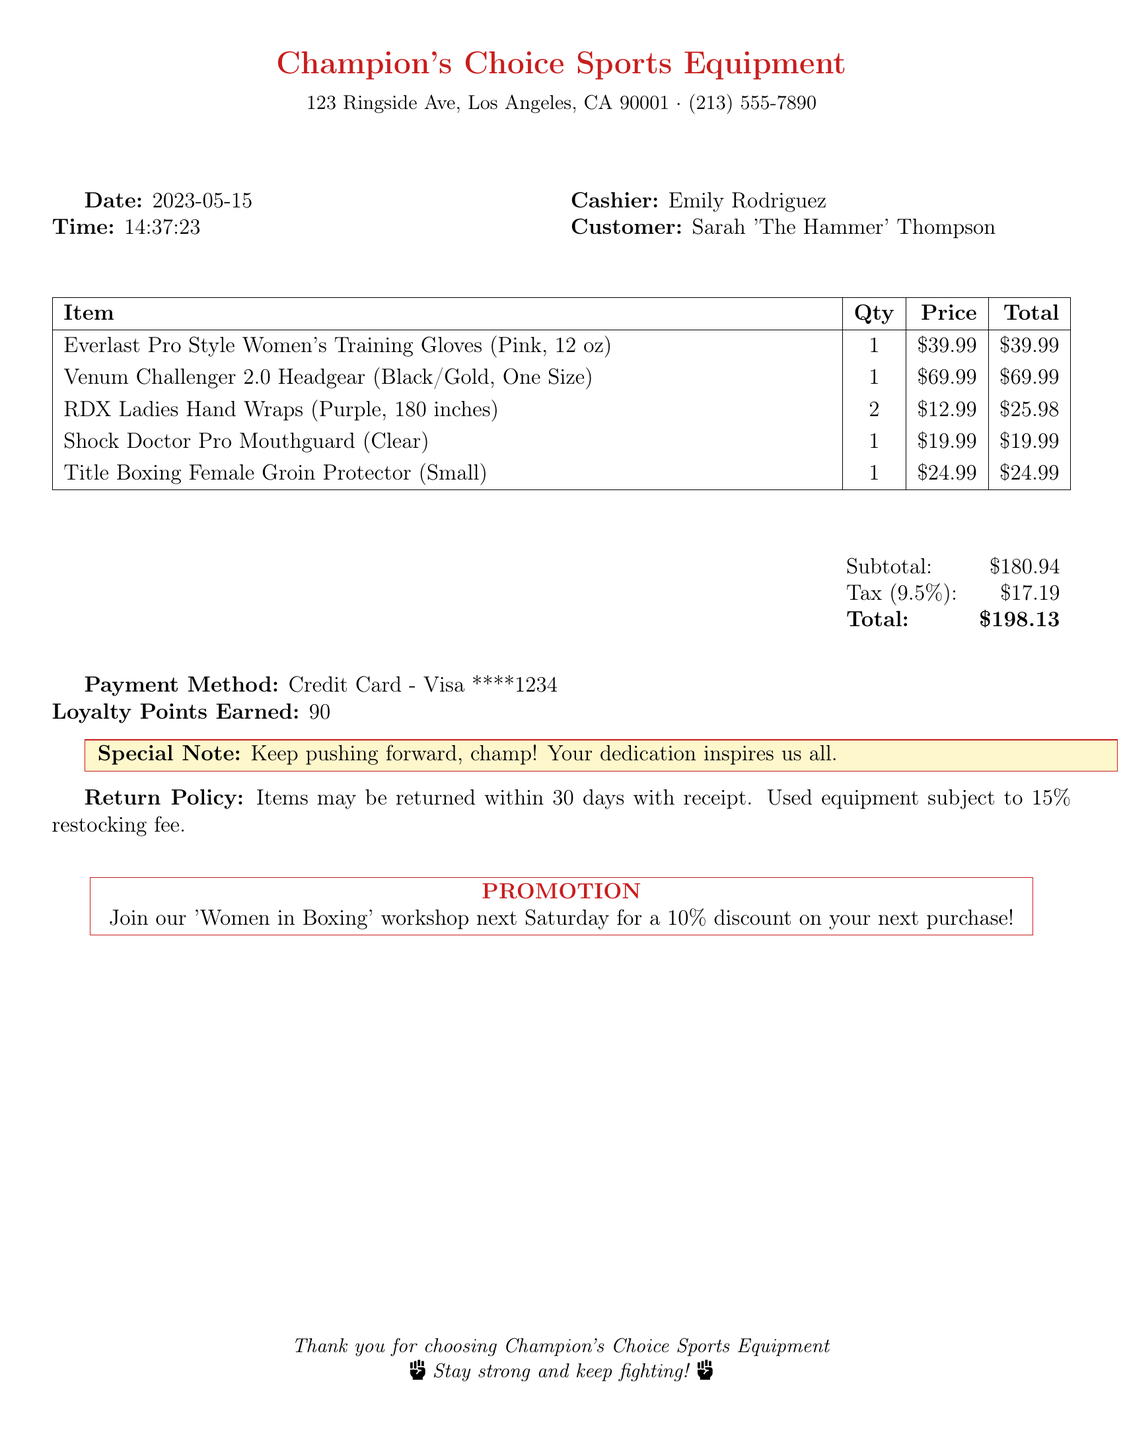What is the store name? The store name is located at the top of the receipt.
Answer: Champion's Choice Sports Equipment What is the total amount spent? The total amount is shown at the bottom of the receipt.
Answer: $198.13 What date was the purchase made? The date is listed in the receipt details.
Answer: 2023-05-15 Who is the cashier? The cashier's name is provided in the receipt.
Answer: Emily Rodriguez How many loyalty points were earned? The loyalty points earned are stated near the payment method.
Answer: 90 What is the return policy duration? The return policy is explained in the document.
Answer: 30 days Which item has the highest price? The item prices are listed in a table.
Answer: Venum Challenger 2.0 Headgear What was used as a payment method? The payment method is specified in the receipt details.
Answer: Credit Card - Visa ****1234 Is there a promotion mentioned in the receipt? The receipt includes a section for promotions and offers.
Answer: Yes, a 'Women in Boxing' workshop 